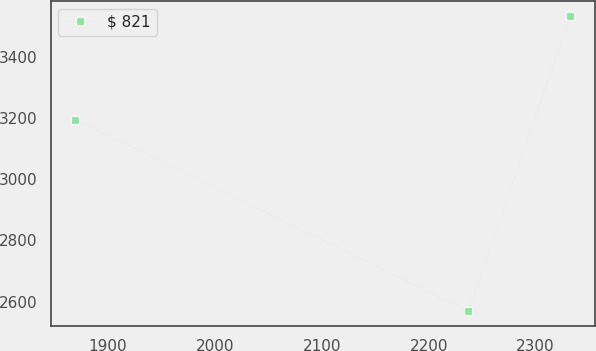Convert chart to OTSL. <chart><loc_0><loc_0><loc_500><loc_500><line_chart><ecel><fcel>$ 821<nl><fcel>1869.95<fcel>3194.75<nl><fcel>2237.2<fcel>2567.84<nl><fcel>2332.34<fcel>3533.86<nl></chart> 